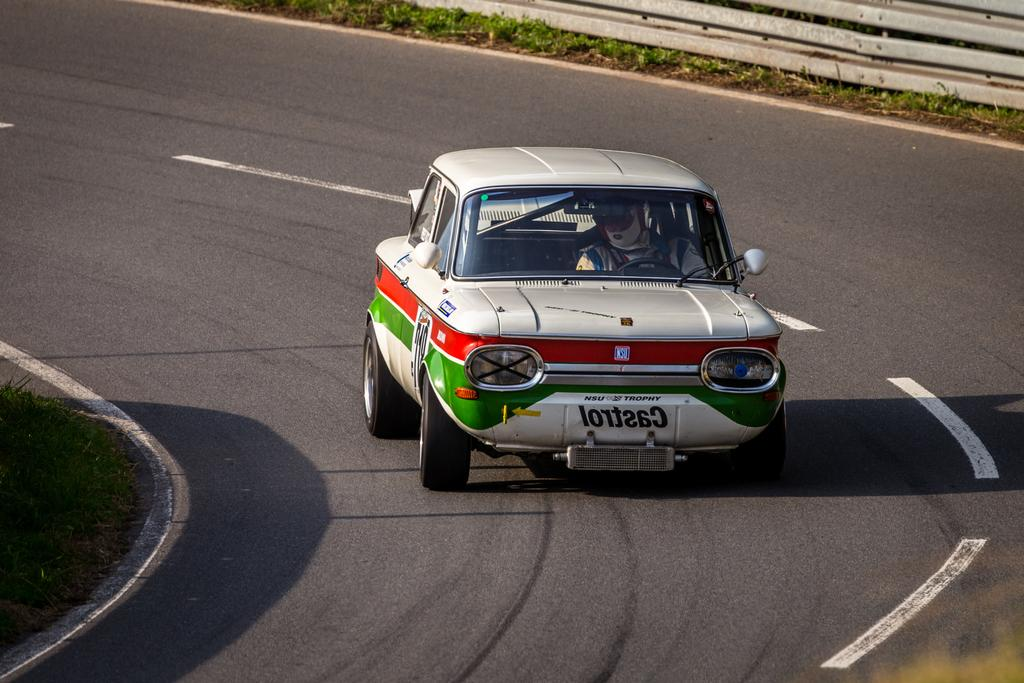What is the main subject of the image? There is a person in the image. What is the person doing in the image? The person is sitting in a car and driving it. Can you describe the car in the image? The car has multiple colors. Is there a fight happening between the person and a kitten in the image? No, there is no fight or kitten present in the image. 